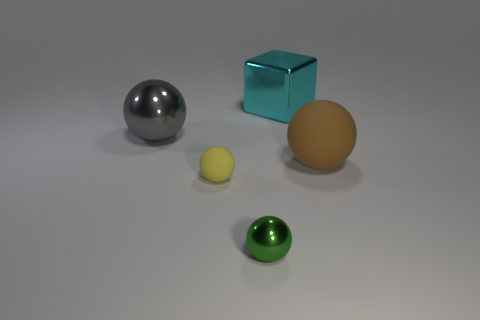There is a large object that is to the right of the small green thing and in front of the metallic block; what is its material?
Provide a short and direct response. Rubber. What is the color of the metallic object that is behind the large gray metallic thing?
Provide a succinct answer. Cyan. Are there more yellow balls behind the cyan object than large matte spheres?
Make the answer very short. No. What number of other things are there of the same size as the brown rubber object?
Offer a very short reply. 2. There is a brown matte sphere; how many small green metallic balls are in front of it?
Your answer should be very brief. 1. Is the number of large things that are behind the large cyan metallic object the same as the number of gray metallic balls right of the small green sphere?
Offer a very short reply. Yes. What size is the green thing that is the same shape as the yellow object?
Offer a terse response. Small. The shiny object on the left side of the tiny matte object has what shape?
Your answer should be compact. Sphere. Do the large object that is left of the cyan metal cube and the large sphere that is right of the large cyan cube have the same material?
Provide a short and direct response. No. There is a large cyan metal thing; what shape is it?
Your response must be concise. Cube. 